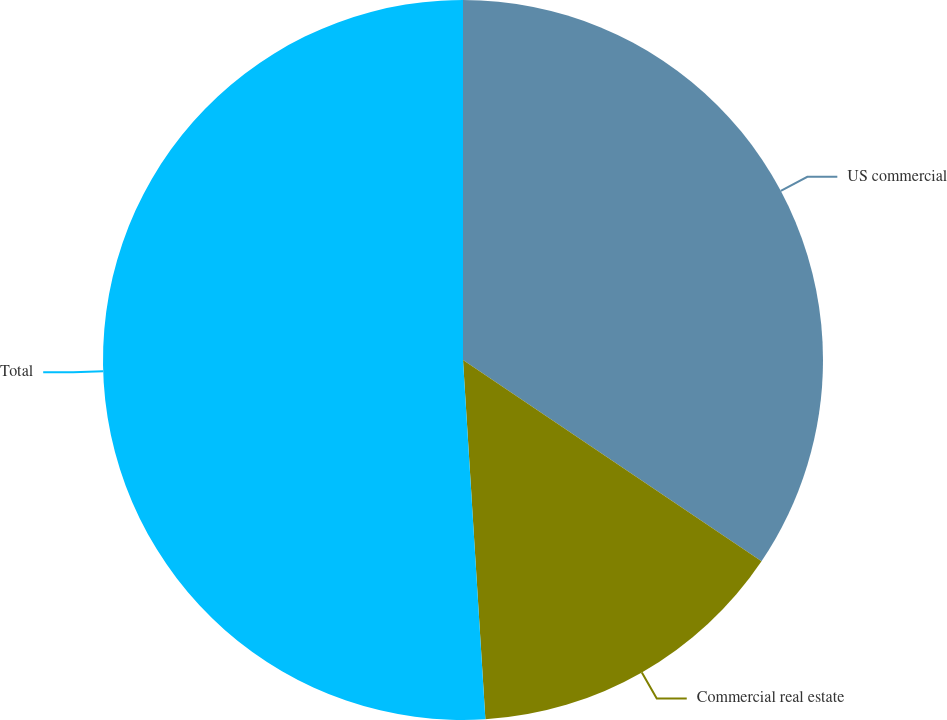<chart> <loc_0><loc_0><loc_500><loc_500><pie_chart><fcel>US commercial<fcel>Commercial real estate<fcel>Total<nl><fcel>34.44%<fcel>14.57%<fcel>50.99%<nl></chart> 